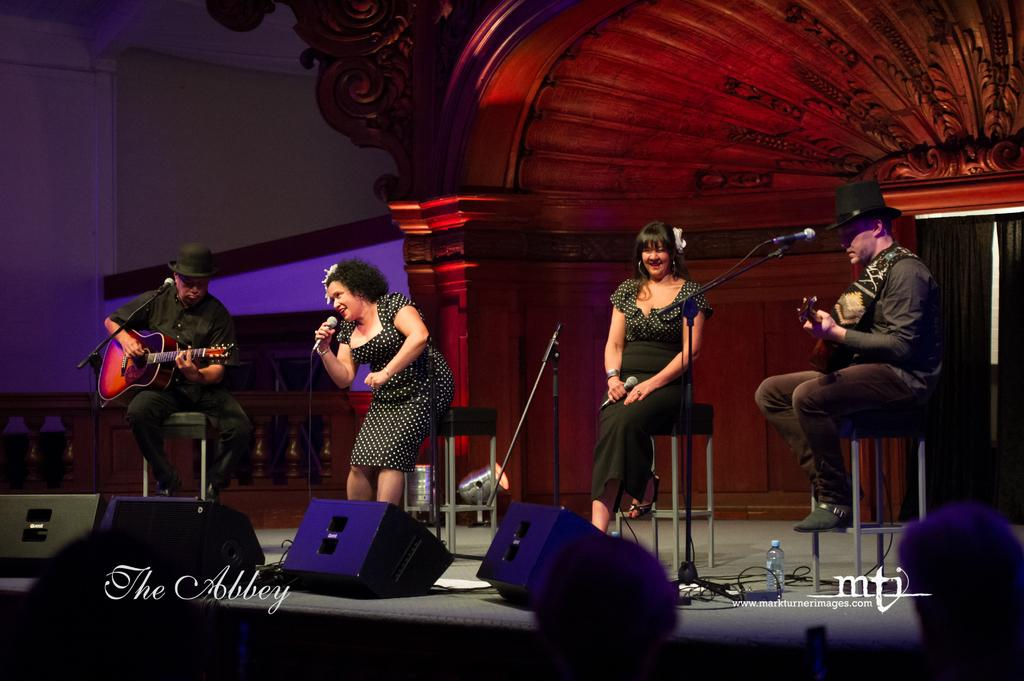How many people are in the image? There are four people in the image, two men and two women. What are the men doing in the image? The men are playing guitar. What are the women doing in the image? The women are singing into microphones. What activity are they engaged in together? They are presenting a stage show. What type of brush is being used by the women to paint the border in the image? There is no brush or painting activity present in the image. The women are singing into microphones, and there is no mention of a border. 